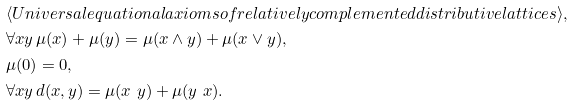<formula> <loc_0><loc_0><loc_500><loc_500>& \langle U n i v e r s a l e q u a t i o n a l a x i o m s o f r e l a t i v e l y c o m p l e m e n t e d d i s t r i b u t i v e l a t t i c e s \rangle , \\ & \forall x y \, \mu ( x ) + \mu ( y ) = \mu ( x \wedge y ) + \mu ( x \vee y ) , \\ & \mu ( 0 ) = 0 , \\ & \forall x y \, d ( x , y ) = \mu ( x \ y ) + \mu ( y \ x ) .</formula> 